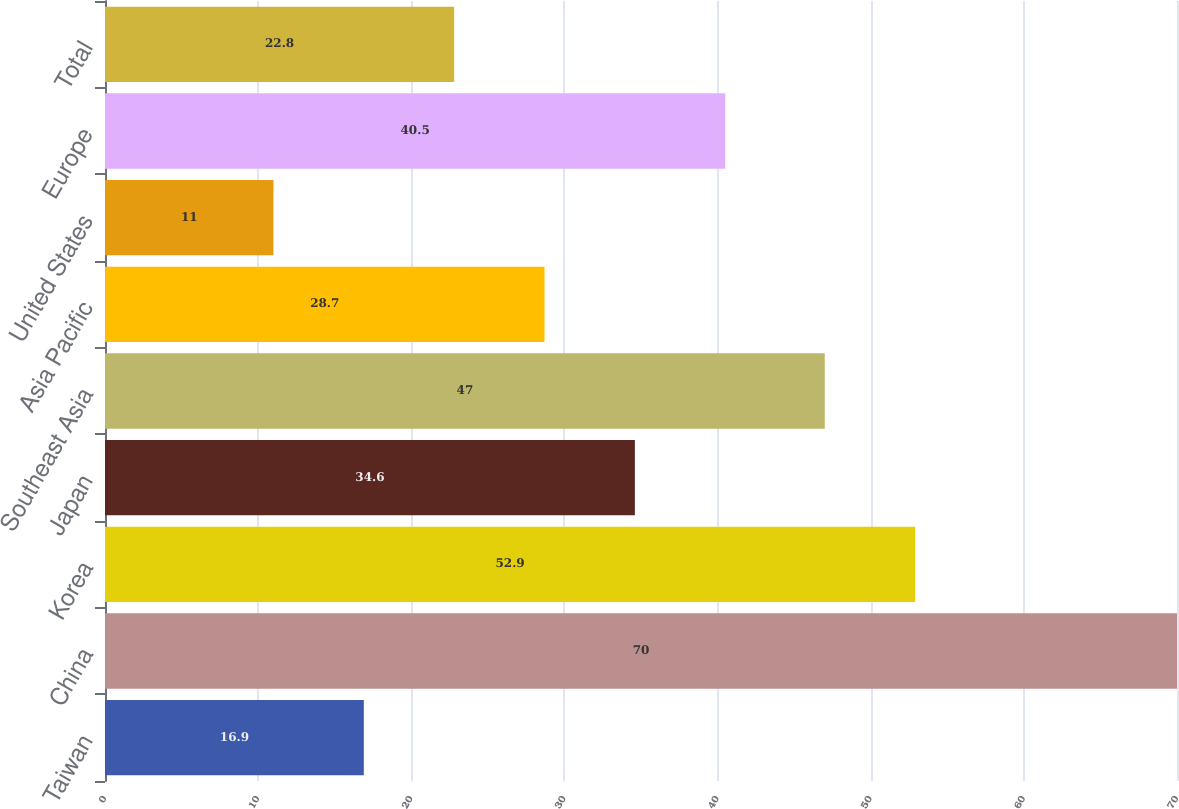<chart> <loc_0><loc_0><loc_500><loc_500><bar_chart><fcel>Taiwan<fcel>China<fcel>Korea<fcel>Japan<fcel>Southeast Asia<fcel>Asia Pacific<fcel>United States<fcel>Europe<fcel>Total<nl><fcel>16.9<fcel>70<fcel>52.9<fcel>34.6<fcel>47<fcel>28.7<fcel>11<fcel>40.5<fcel>22.8<nl></chart> 